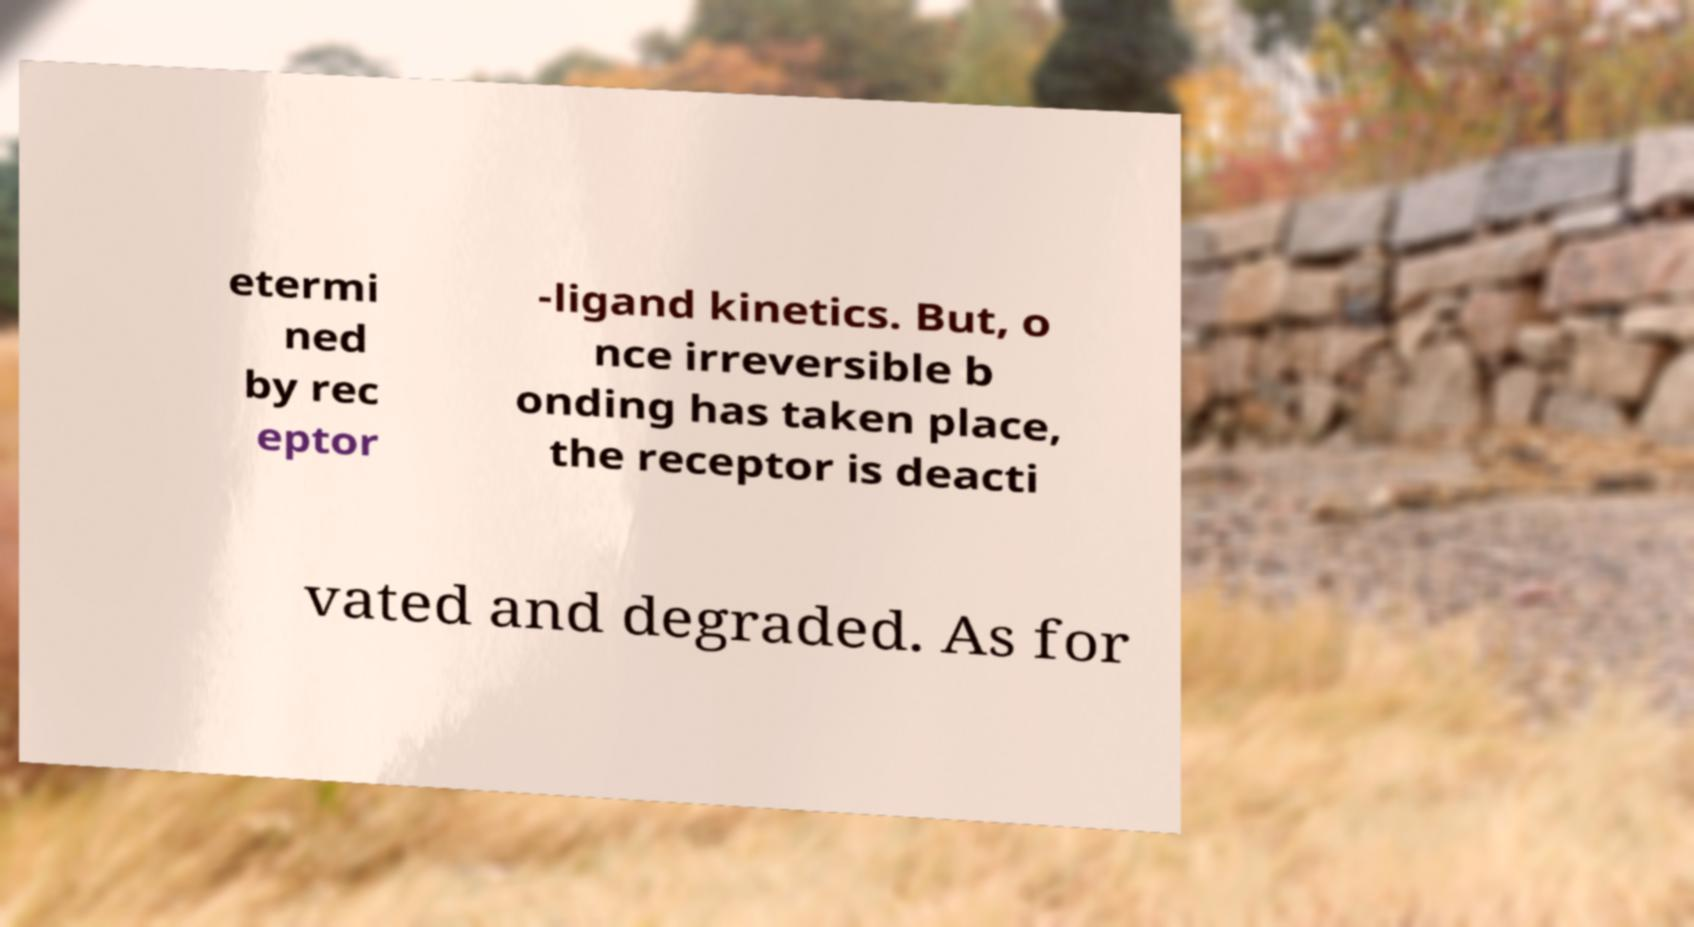There's text embedded in this image that I need extracted. Can you transcribe it verbatim? etermi ned by rec eptor -ligand kinetics. But, o nce irreversible b onding has taken place, the receptor is deacti vated and degraded. As for 